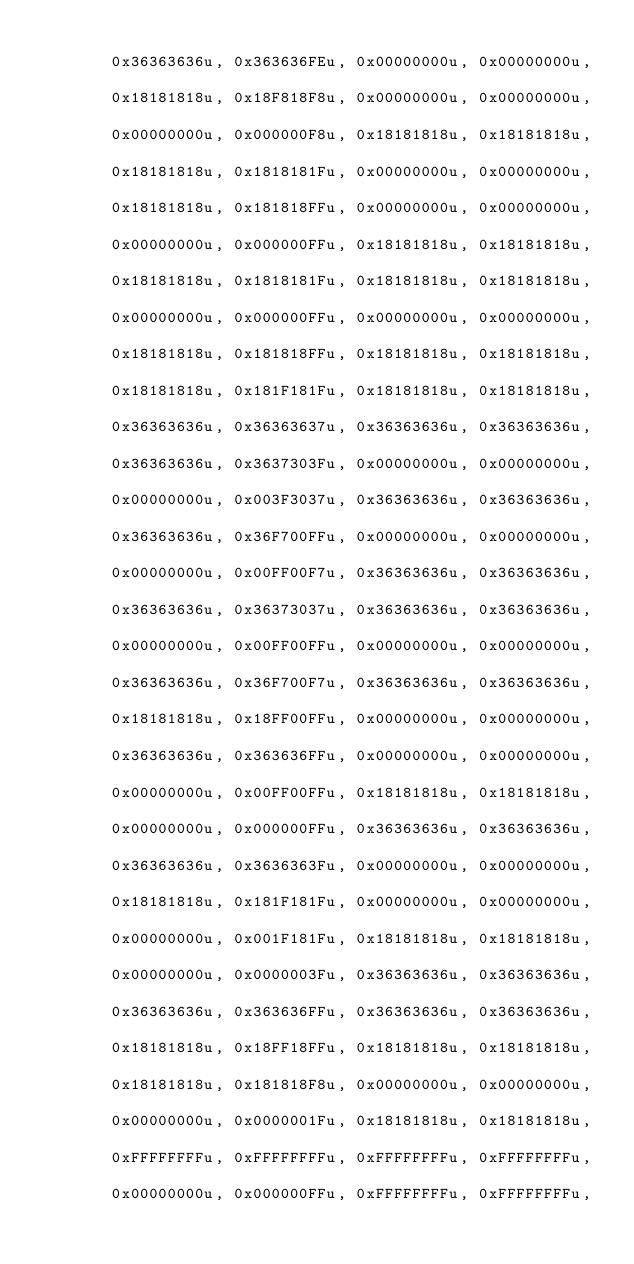<code> <loc_0><loc_0><loc_500><loc_500><_C_>
		0x36363636u, 0x363636FEu, 0x00000000u, 0x00000000u,

		0x18181818u, 0x18F818F8u, 0x00000000u, 0x00000000u,

		0x00000000u, 0x000000F8u, 0x18181818u, 0x18181818u,

		0x18181818u, 0x1818181Fu, 0x00000000u, 0x00000000u,

		0x18181818u, 0x181818FFu, 0x00000000u, 0x00000000u,

		0x00000000u, 0x000000FFu, 0x18181818u, 0x18181818u,

		0x18181818u, 0x1818181Fu, 0x18181818u, 0x18181818u,

		0x00000000u, 0x000000FFu, 0x00000000u, 0x00000000u,

		0x18181818u, 0x181818FFu, 0x18181818u, 0x18181818u,

		0x18181818u, 0x181F181Fu, 0x18181818u, 0x18181818u,

		0x36363636u, 0x36363637u, 0x36363636u, 0x36363636u,

		0x36363636u, 0x3637303Fu, 0x00000000u, 0x00000000u,

		0x00000000u, 0x003F3037u, 0x36363636u, 0x36363636u,

		0x36363636u, 0x36F700FFu, 0x00000000u, 0x00000000u,

		0x00000000u, 0x00FF00F7u, 0x36363636u, 0x36363636u,

		0x36363636u, 0x36373037u, 0x36363636u, 0x36363636u,

		0x00000000u, 0x00FF00FFu, 0x00000000u, 0x00000000u,

		0x36363636u, 0x36F700F7u, 0x36363636u, 0x36363636u,

		0x18181818u, 0x18FF00FFu, 0x00000000u, 0x00000000u,

		0x36363636u, 0x363636FFu, 0x00000000u, 0x00000000u,

		0x00000000u, 0x00FF00FFu, 0x18181818u, 0x18181818u,

		0x00000000u, 0x000000FFu, 0x36363636u, 0x36363636u,

		0x36363636u, 0x3636363Fu, 0x00000000u, 0x00000000u,

		0x18181818u, 0x181F181Fu, 0x00000000u, 0x00000000u,

		0x00000000u, 0x001F181Fu, 0x18181818u, 0x18181818u,

		0x00000000u, 0x0000003Fu, 0x36363636u, 0x36363636u,

		0x36363636u, 0x363636FFu, 0x36363636u, 0x36363636u,

		0x18181818u, 0x18FF18FFu, 0x18181818u, 0x18181818u,

		0x18181818u, 0x181818F8u, 0x00000000u, 0x00000000u,

		0x00000000u, 0x0000001Fu, 0x18181818u, 0x18181818u,

		0xFFFFFFFFu, 0xFFFFFFFFu, 0xFFFFFFFFu, 0xFFFFFFFFu,

		0x00000000u, 0x000000FFu, 0xFFFFFFFFu, 0xFFFFFFFFu,
</code> 